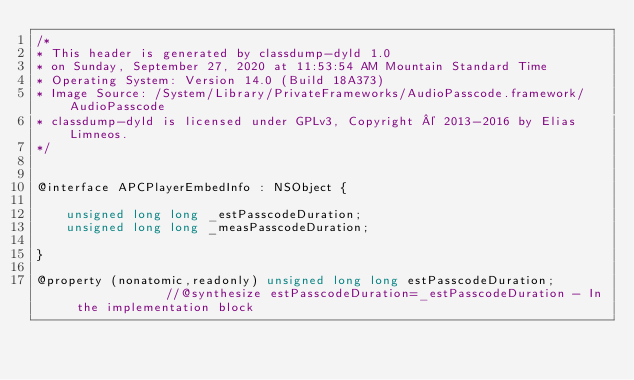Convert code to text. <code><loc_0><loc_0><loc_500><loc_500><_C_>/*
* This header is generated by classdump-dyld 1.0
* on Sunday, September 27, 2020 at 11:53:54 AM Mountain Standard Time
* Operating System: Version 14.0 (Build 18A373)
* Image Source: /System/Library/PrivateFrameworks/AudioPasscode.framework/AudioPasscode
* classdump-dyld is licensed under GPLv3, Copyright © 2013-2016 by Elias Limneos.
*/


@interface APCPlayerEmbedInfo : NSObject {

	unsigned long long _estPasscodeDuration;
	unsigned long long _measPasscodeDuration;

}

@property (nonatomic,readonly) unsigned long long estPasscodeDuration;              //@synthesize estPasscodeDuration=_estPasscodeDuration - In the implementation block</code> 